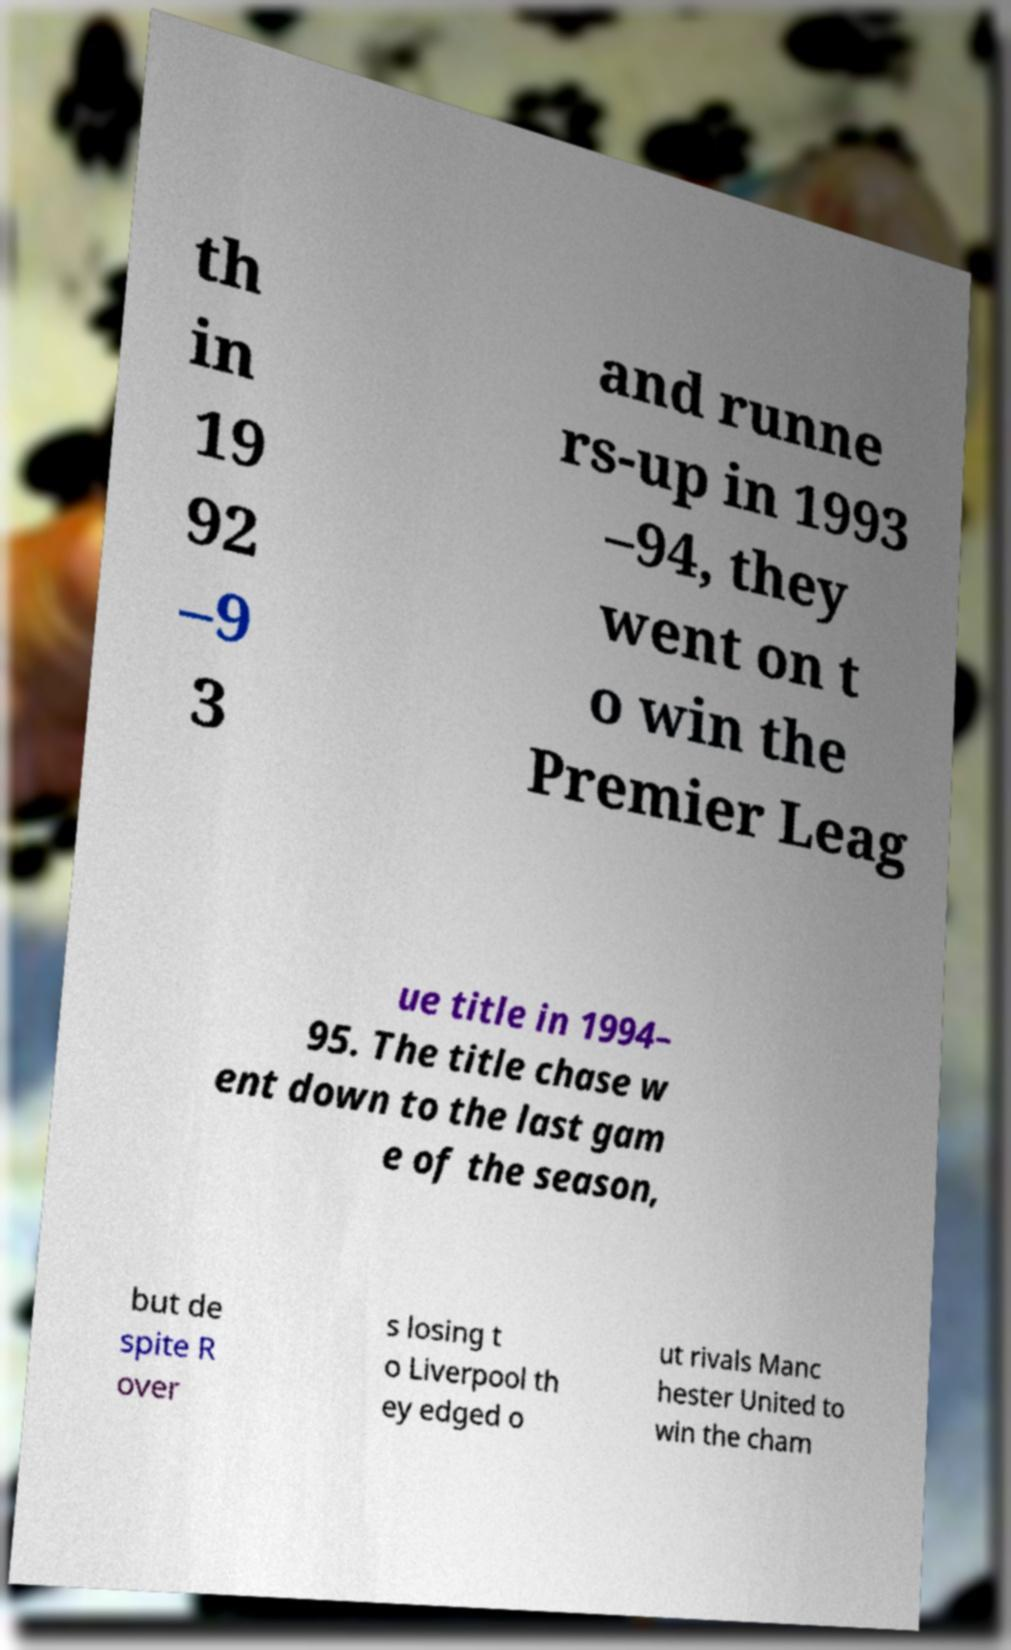Could you assist in decoding the text presented in this image and type it out clearly? th in 19 92 –9 3 and runne rs-up in 1993 –94, they went on t o win the Premier Leag ue title in 1994– 95. The title chase w ent down to the last gam e of the season, but de spite R over s losing t o Liverpool th ey edged o ut rivals Manc hester United to win the cham 